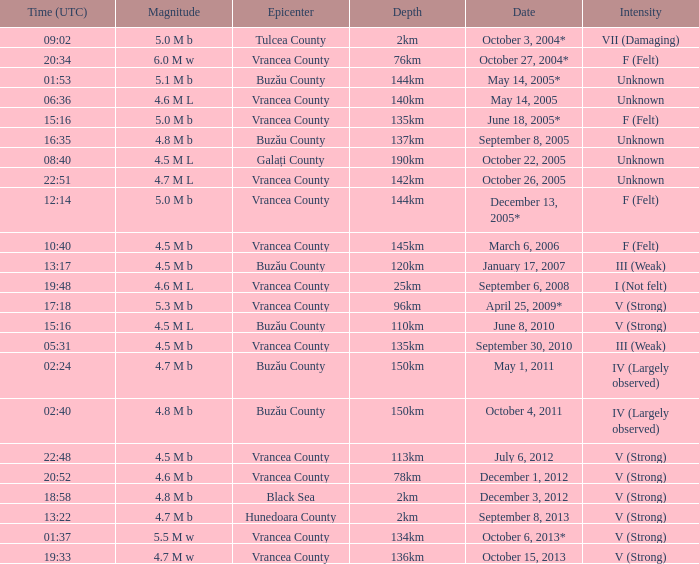What is the depth of the quake that occurred at 19:48? 25km. 